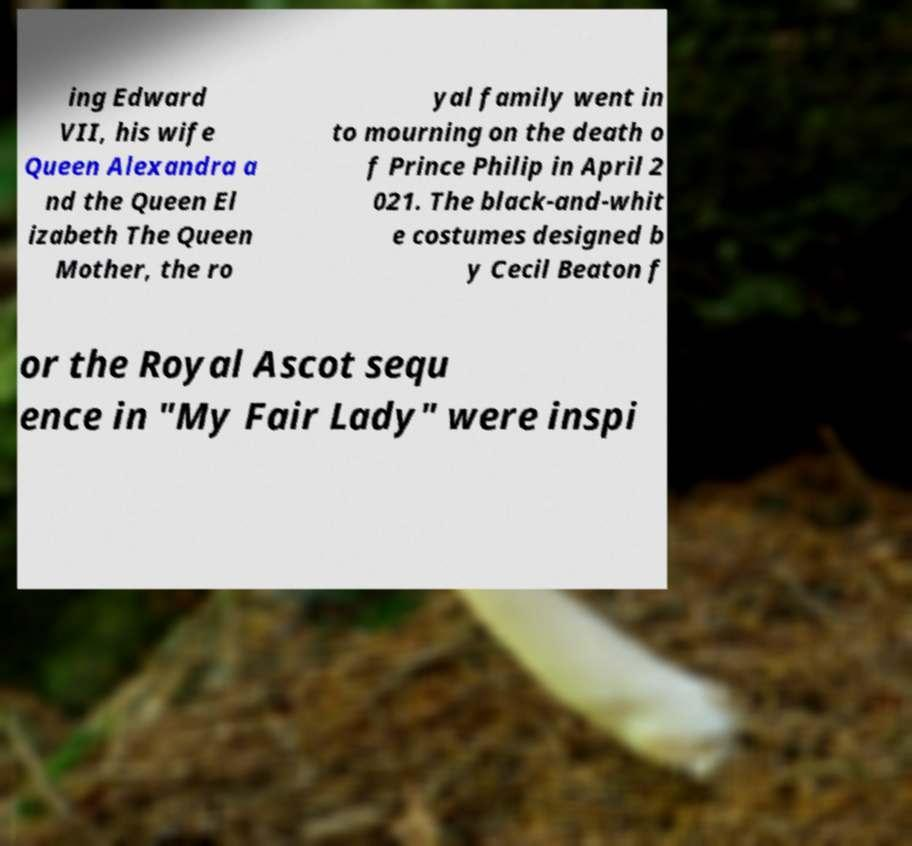Can you accurately transcribe the text from the provided image for me? ing Edward VII, his wife Queen Alexandra a nd the Queen El izabeth The Queen Mother, the ro yal family went in to mourning on the death o f Prince Philip in April 2 021. The black-and-whit e costumes designed b y Cecil Beaton f or the Royal Ascot sequ ence in "My Fair Lady" were inspi 